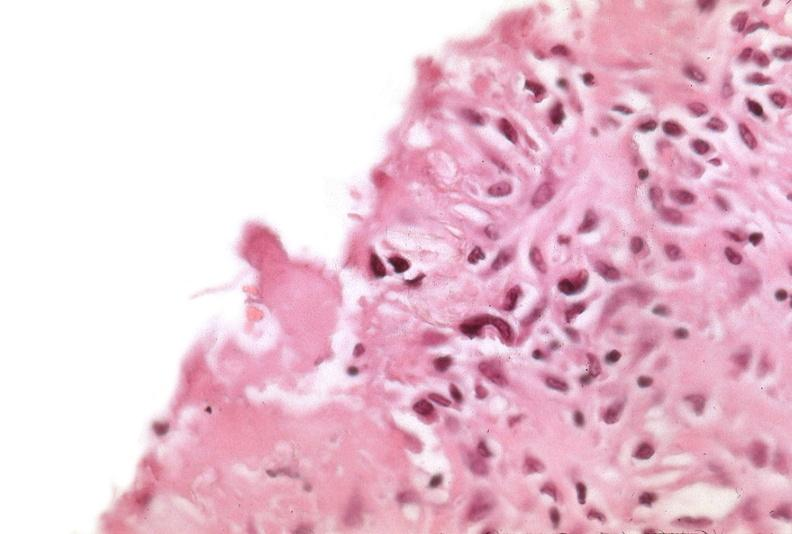does this image show pleura, talc reaction?
Answer the question using a single word or phrase. Yes 